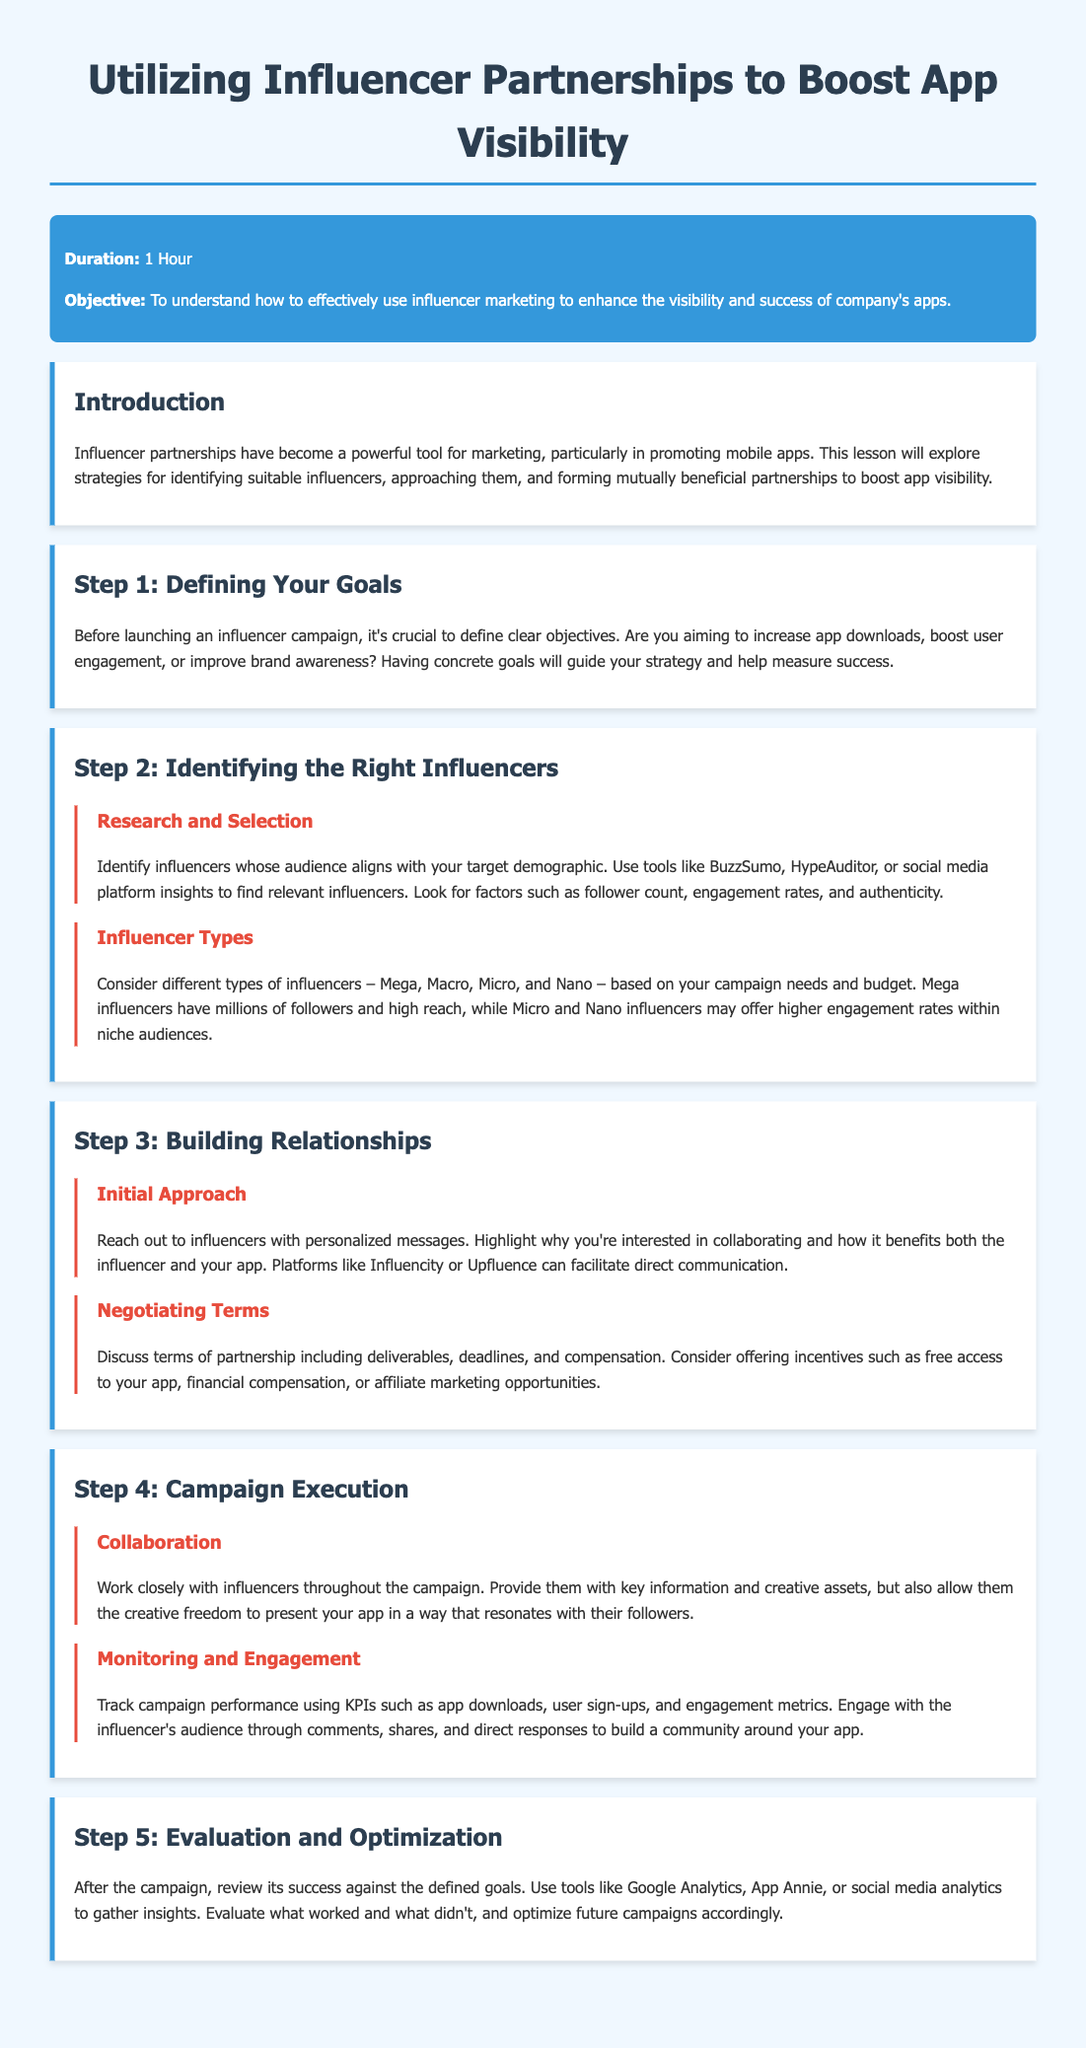What is the duration of the lesson? The document states that the duration of the lesson is mentioned in the lesson info section.
Answer: 1 Hour What is the primary objective of the lesson? The objective is outlined in the lesson info section and explains what the lesson aims to achieve.
Answer: To understand how to effectively use influencer marketing What is the first step in the guide? The document lists the steps in sequential order, and the first step is detailed in the steps section.
Answer: Defining Your Goals What tools are suggested for identifying influencers? The document lists specific tools in the identifying influencers section that can aid in influencer selection.
Answer: BuzzSumo, HypeAuditor What type of influencers may offer higher engagement rates within niche audiences? The document outlines different types of influencers and their characteristics.
Answer: Micro and Nano What should be tracked during campaign execution? The document specifically mentions the monitoring of certain metrics in the execution step.
Answer: Campaign performance What are some key performance indicators mentioned? The document provides examples of KPIs relevant to the campaign performance metrics.
Answer: App downloads, user sign-ups, engagement metrics What should be evaluated after the campaign? The document specifies what should be reviewed in the evaluation step, indicating a process for assessment.
Answer: Success against the defined goals What is a recommended platform for initial outreach to influencers? The document suggests platforms to facilitate communication in the relationships section.
Answer: Influencity 